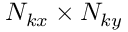Convert formula to latex. <formula><loc_0><loc_0><loc_500><loc_500>N _ { k x } \times N _ { k y }</formula> 